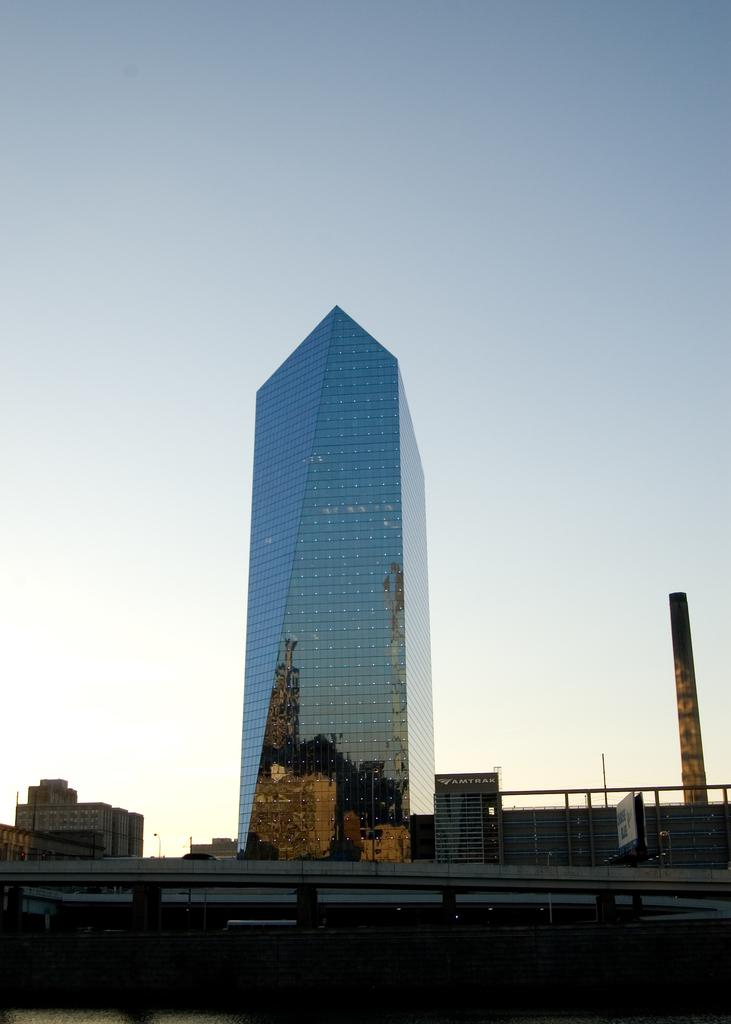What type of structure is present in the image? There is a flyover in the image. What else can be seen in the image besides the flyover? There are buildings and boards visible in the image. What is visible in the background of the image? The sky is visible in the background of the image. Where is the rabbit hiding under the flyover in the image? There is no rabbit present in the image. What type of tent can be seen near the buildings in the image? There is no tent present in the image; only buildings, boards, and a flyover are visible. 